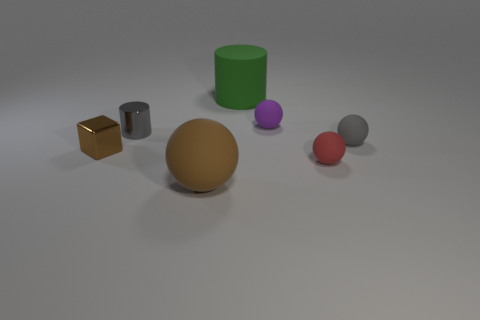Does the tiny purple object have the same shape as the big green rubber thing?
Offer a terse response. No. How many large green objects have the same shape as the gray shiny object?
Keep it short and to the point. 1. There is a brown matte object; what number of rubber cylinders are in front of it?
Your response must be concise. 0. There is a big rubber object in front of the big green matte cylinder; is it the same color as the shiny cylinder?
Your answer should be very brief. No. How many gray metallic cylinders are the same size as the red ball?
Provide a succinct answer. 1. What shape is the purple thing that is made of the same material as the brown ball?
Your answer should be very brief. Sphere. Is there a tiny rubber thing of the same color as the metal cube?
Offer a terse response. No. What material is the large brown thing?
Provide a short and direct response. Rubber. How many things are either big matte cylinders or tiny rubber cylinders?
Your answer should be very brief. 1. There is a cylinder that is to the left of the brown sphere; how big is it?
Your answer should be compact. Small. 